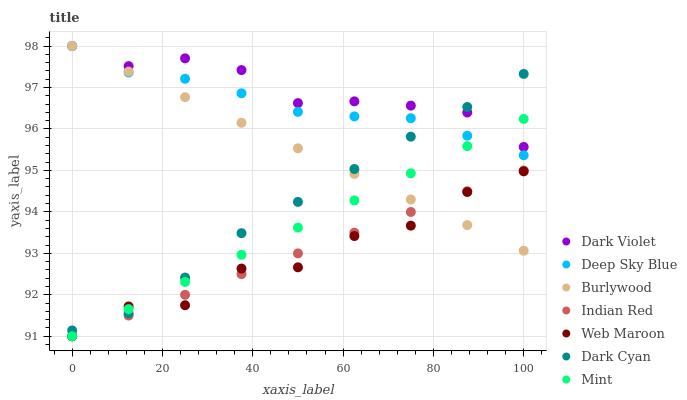Does Web Maroon have the minimum area under the curve?
Answer yes or no. Yes. Does Dark Violet have the maximum area under the curve?
Answer yes or no. Yes. Does Burlywood have the minimum area under the curve?
Answer yes or no. No. Does Burlywood have the maximum area under the curve?
Answer yes or no. No. Is Mint the smoothest?
Answer yes or no. Yes. Is Web Maroon the roughest?
Answer yes or no. Yes. Is Burlywood the smoothest?
Answer yes or no. No. Is Burlywood the roughest?
Answer yes or no. No. Does Web Maroon have the lowest value?
Answer yes or no. Yes. Does Burlywood have the lowest value?
Answer yes or no. No. Does Burlywood have the highest value?
Answer yes or no. Yes. Does Web Maroon have the highest value?
Answer yes or no. No. Is Web Maroon less than Deep Sky Blue?
Answer yes or no. Yes. Is Deep Sky Blue greater than Indian Red?
Answer yes or no. Yes. Does Dark Cyan intersect Mint?
Answer yes or no. Yes. Is Dark Cyan less than Mint?
Answer yes or no. No. Is Dark Cyan greater than Mint?
Answer yes or no. No. Does Web Maroon intersect Deep Sky Blue?
Answer yes or no. No. 